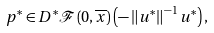<formula> <loc_0><loc_0><loc_500><loc_500>p ^ { \ast } \in D ^ { \ast } \mathcal { F } \left ( 0 , \overline { x } \right ) \left ( - \left \| u ^ { \ast } \right \| ^ { - 1 } u ^ { \ast } \right ) ,</formula> 